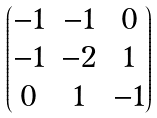<formula> <loc_0><loc_0><loc_500><loc_500>\begin{pmatrix} - 1 & - 1 & 0 \\ - 1 & - 2 & 1 \\ 0 & 1 & - 1 \end{pmatrix}</formula> 